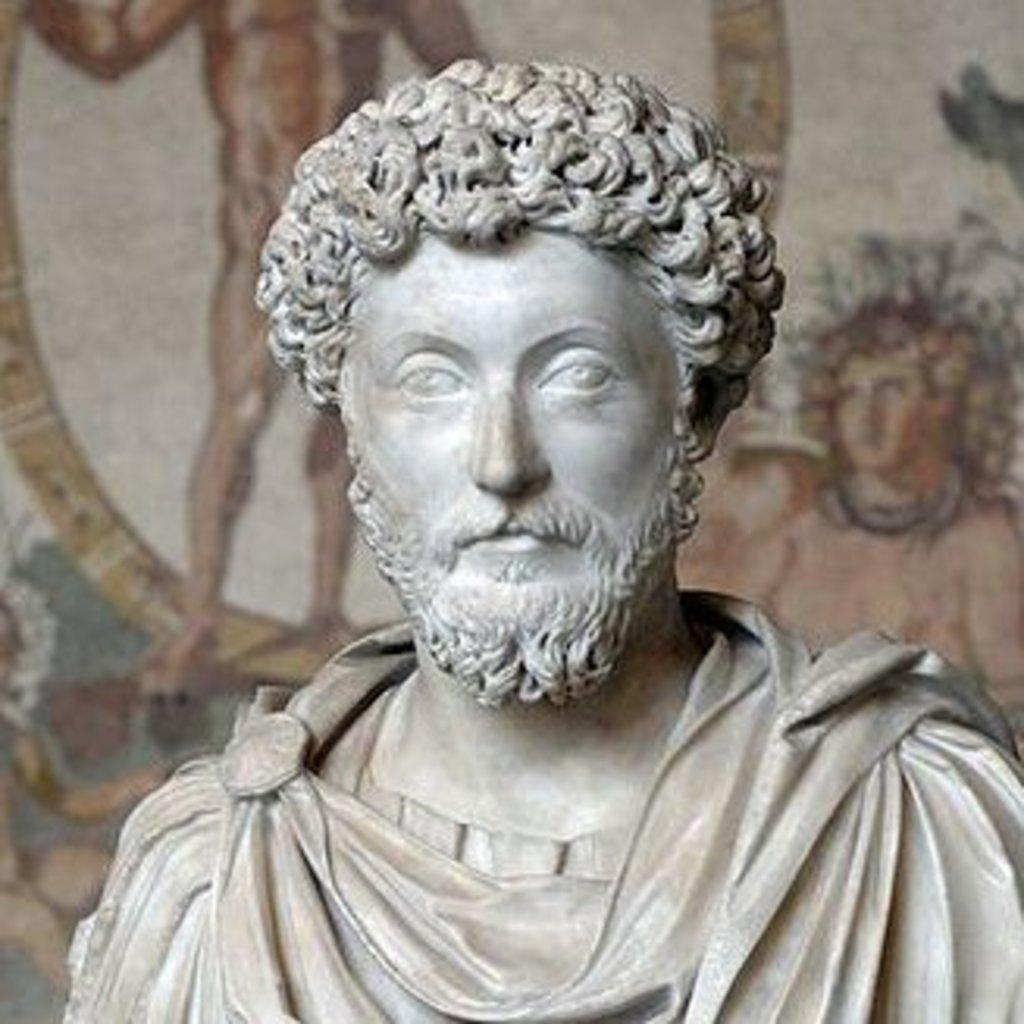What is the main subject of the image? There is a statue of a man in the image. Can you describe the statue's surroundings? In the background of the image, there is a wall with paintings. What type of wine is being served at the event depicted in the image? There is no event or wine present in the image; it features a statue of a man and a wall with paintings. How many muscles can be seen on the statue in the image? The number of muscles on the statue cannot be determined from the image alone, as it does not provide a detailed view of the statue's anatomy. 